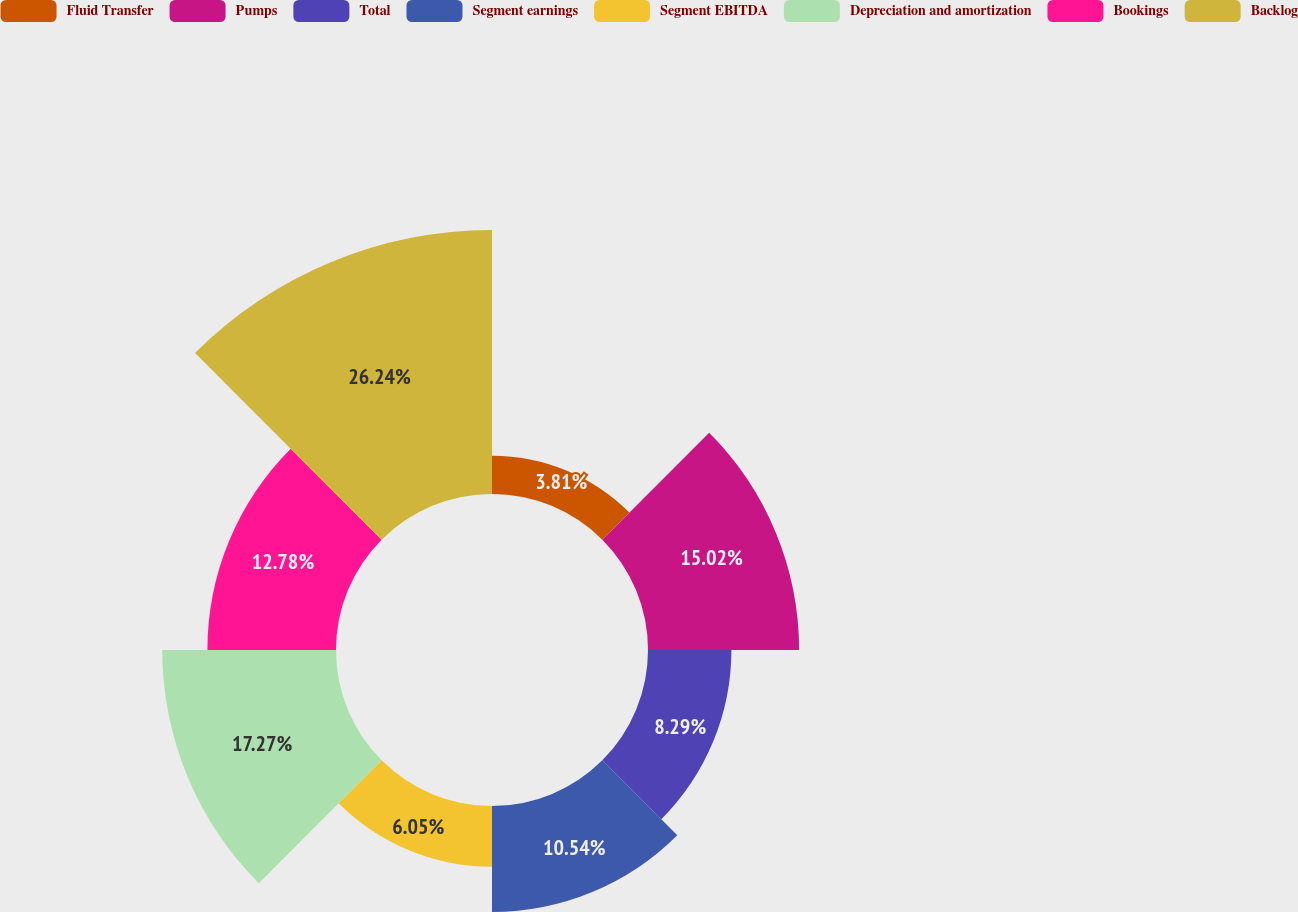Convert chart. <chart><loc_0><loc_0><loc_500><loc_500><pie_chart><fcel>Fluid Transfer<fcel>Pumps<fcel>Total<fcel>Segment earnings<fcel>Segment EBITDA<fcel>Depreciation and amortization<fcel>Bookings<fcel>Backlog<nl><fcel>3.81%<fcel>15.02%<fcel>8.29%<fcel>10.54%<fcel>6.05%<fcel>17.27%<fcel>12.78%<fcel>26.24%<nl></chart> 